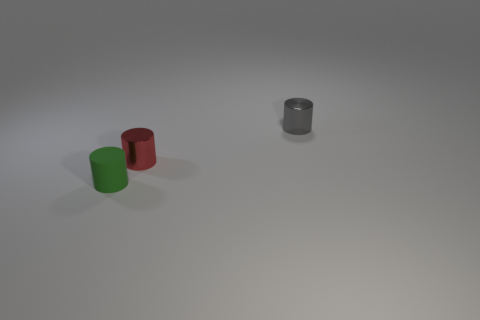Subtract all cyan cylinders. Subtract all green balls. How many cylinders are left? 3 Add 1 tiny gray metallic cylinders. How many objects exist? 4 Subtract all metallic cylinders. Subtract all gray metal cylinders. How many objects are left? 0 Add 1 gray cylinders. How many gray cylinders are left? 2 Add 3 small green rubber things. How many small green rubber things exist? 4 Subtract 0 cyan blocks. How many objects are left? 3 